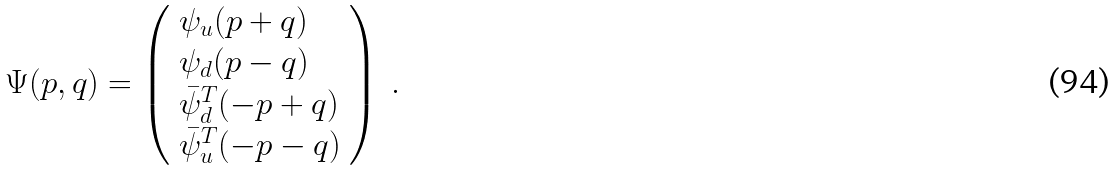Convert formula to latex. <formula><loc_0><loc_0><loc_500><loc_500>\Psi ( p , q ) = \left ( \begin{array} { l } { { \psi _ { u } ( p + q ) } } \\ { { \psi _ { d } ( p - q ) } } \\ { { \bar { \psi } _ { d } ^ { T } ( - p + q ) } } \\ { { \bar { \psi } _ { u } ^ { T } ( - p - q ) } } \end{array} \right ) \ .</formula> 